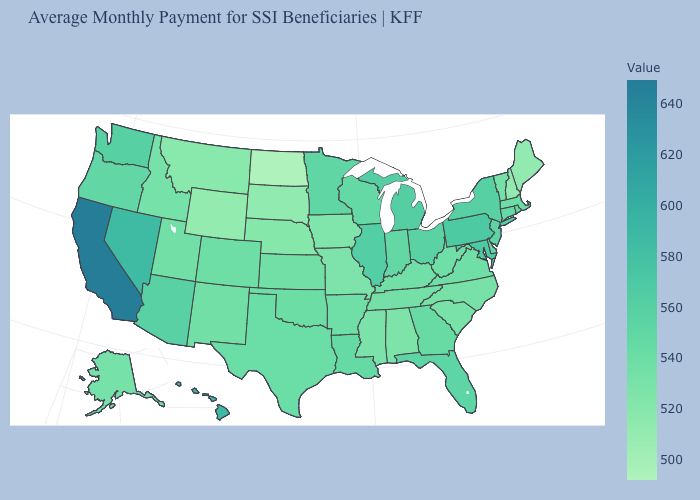Which states have the lowest value in the USA?
Quick response, please. North Dakota. Does Montana have the highest value in the West?
Quick response, please. No. Which states have the lowest value in the USA?
Concise answer only. North Dakota. 